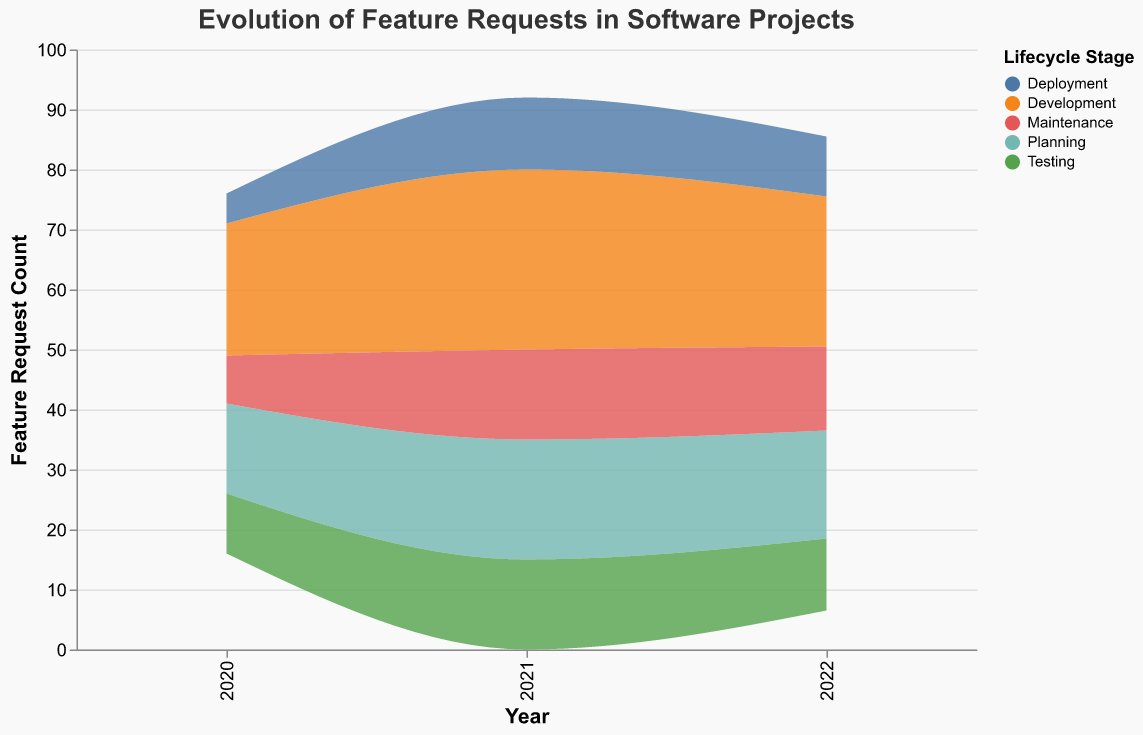What is the title of the figure? The title is usually positioned at the top of the chart and provides a brief description of the figure. Here, it is 'Evolution of Feature Requests in Software Projects'.
Answer: Evolution of Feature Requests in Software Projects Which lifecycle stage has the highest feature request count in 2021? To answer this, look at the highest point on the 'Count' axis for the year 2021 and identify the corresponding 'Lifecycle Stage' from the color legend.
Answer: Development How many feature requests were there in the Planning stage in 2020? Find the area on the stream graph corresponding to the 'Planning' stage in 2020 and read the value on the 'Count' axis. The 'Count' for this year and stage is 15.
Answer: 15 What is the combined total of feature requests in the Development stage across all years? Sum the feature requests for the 'Development' stage for each year: 22 (2020) + 30 (2021) + 25 (2022) = 77.
Answer: 77 Which year saw the highest total number of feature requests? By examining the height of the stack for each year, 2021 appears to have the highest total number of feature requests.
Answer: 2021 What is the feature request count for 'Testing' in 2021? Identify the 'Testing' stage in the year 2021 and check the count from the graph. The count is 15.
Answer: 15 Compare the count of feature requests in the 'Deployment' stage between 2020 and 2022. Look at the 'Deployment' stage counts for both years and compare them: 5 (2020) and 10 (2022).
Answer: 2022 has more How does the trend of feature requests in the 'Maintenance' stage change over the years? Observe the 'Maintenance' stage area in the stream graph over the years 2020-2022, noting the values: 8 (2020), 15 (2021), 14 (2022). It increases initially and then slightly decreases.
Answer: Increases, then slightly decreases Which feature requests are noted in the 'Testing' stage in 2022, and what is their count? Look at the 'Testing' stage section in 2022 and find the corresponding feature requests and count; it is 'Memory Leak Detection' with a count of 12.
Answer: Memory Leak Detection, 12 